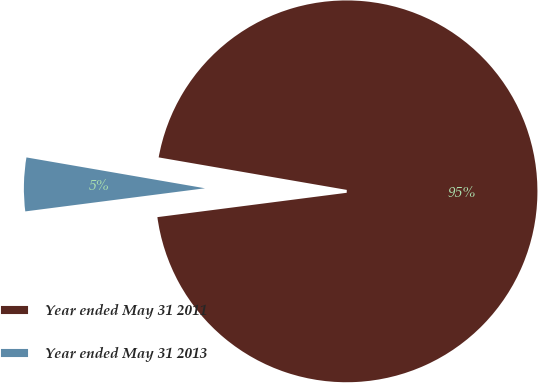Convert chart to OTSL. <chart><loc_0><loc_0><loc_500><loc_500><pie_chart><fcel>Year ended May 31 2011<fcel>Year ended May 31 2013<nl><fcel>95.24%<fcel>4.76%<nl></chart> 